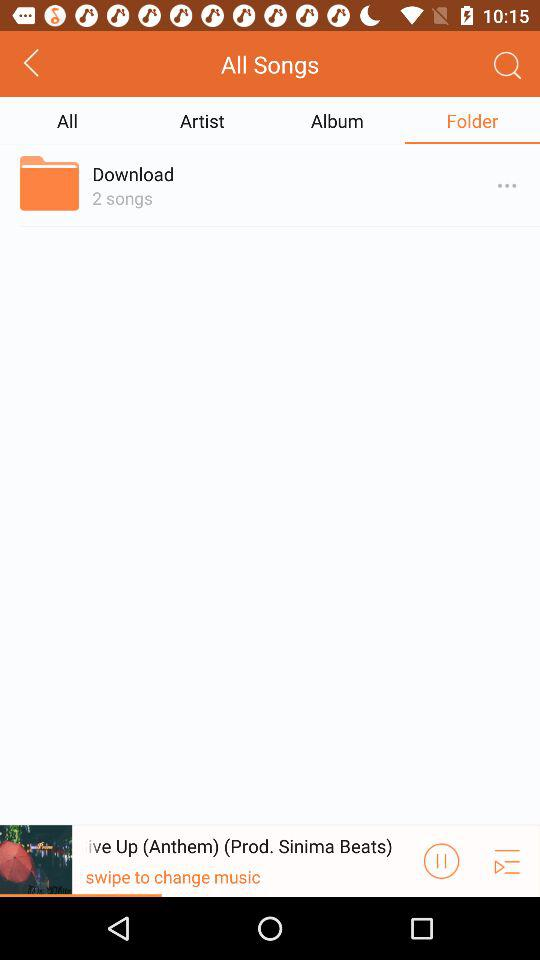How many songs are in the folder?
Answer the question using a single word or phrase. 2 